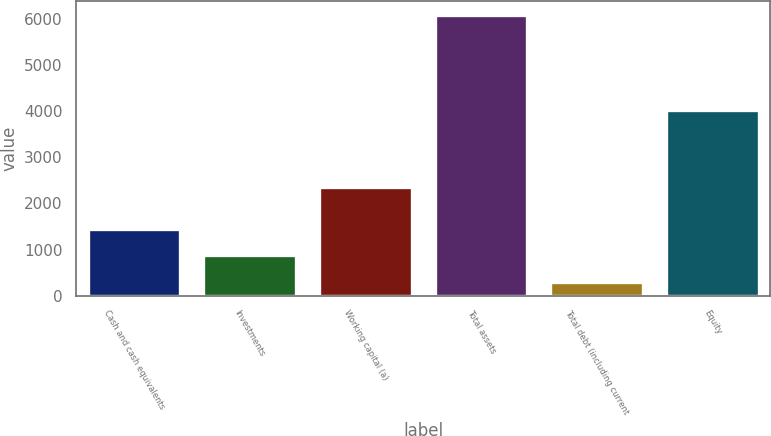Convert chart. <chart><loc_0><loc_0><loc_500><loc_500><bar_chart><fcel>Cash and cash equivalents<fcel>Investments<fcel>Working capital (a)<fcel>Total assets<fcel>Total debt (including current<fcel>Equity<nl><fcel>1455.86<fcel>876.88<fcel>2359<fcel>6087.7<fcel>297.9<fcel>4034.3<nl></chart> 